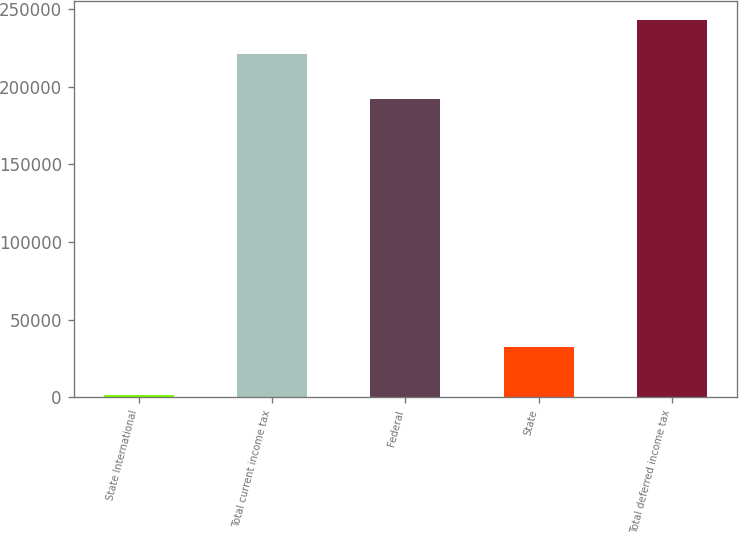Convert chart to OTSL. <chart><loc_0><loc_0><loc_500><loc_500><bar_chart><fcel>State International<fcel>Total current income tax<fcel>Federal<fcel>State<fcel>Total deferred income tax<nl><fcel>1687<fcel>220778<fcel>192267<fcel>32360<fcel>243166<nl></chart> 